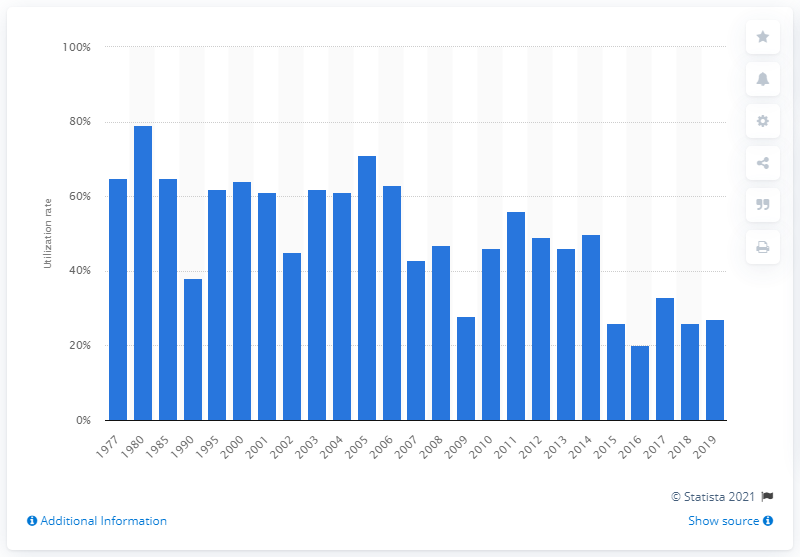Highlight a few significant elements in this photo. In the year 2005, the utilization rate of drilling rigs reached its highest level. 